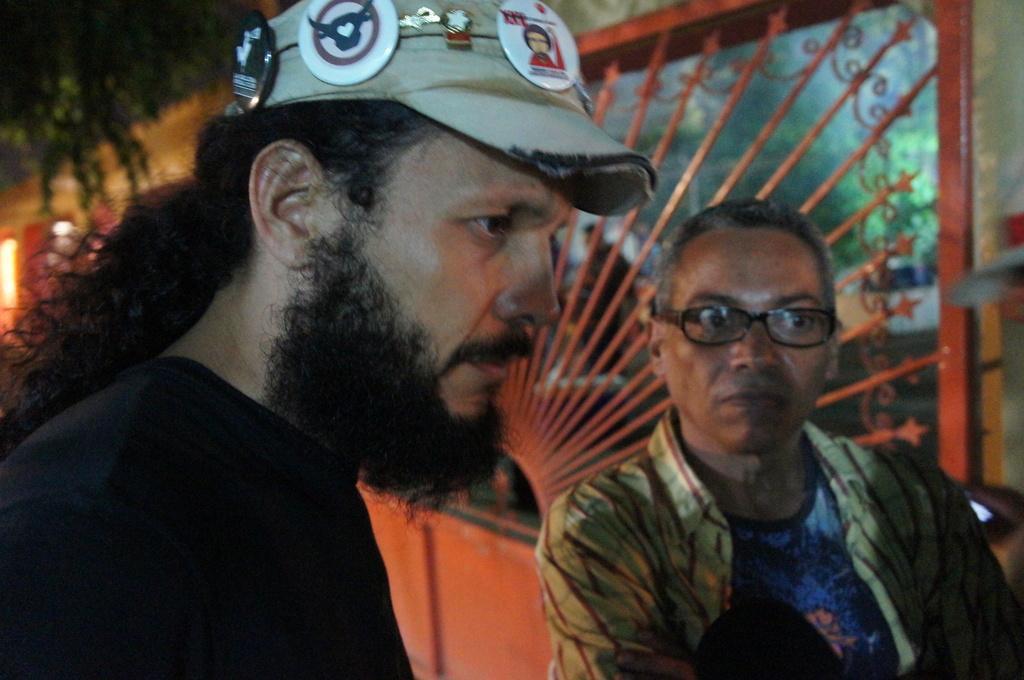Please provide a concise description of this image. In this picture we can see the man with beard and cap on the head, standing in front and looking on the right side. Beside there is a another man with specs is looking into the camera. Behind there is a grill on the wall. 